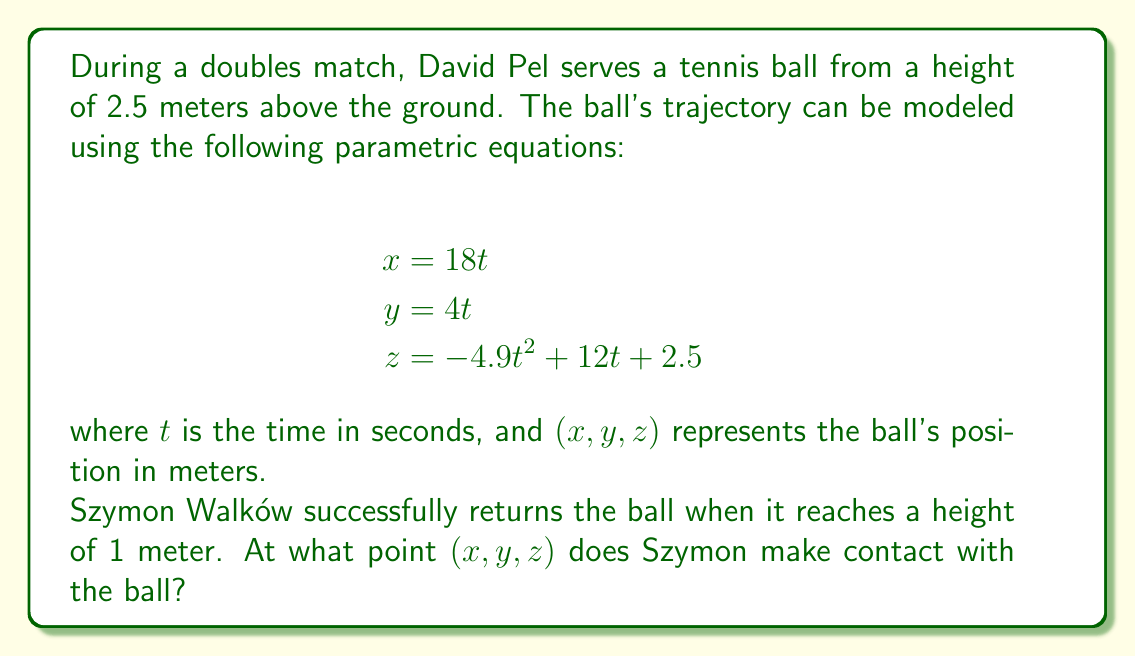Teach me how to tackle this problem. To solve this problem, we need to follow these steps:

1) First, we need to find the time $t$ when the ball reaches a height of 1 meter. This occurs when $z = 1$.

2) We can set up the equation:
   $$1 = -4.9t^2 + 12t + 2.5$$

3) Rearranging the equation:
   $$4.9t^2 - 12t - 1.5 = 0$$

4) This is a quadratic equation in the form $at^2 + bt + c = 0$, where:
   $a = 4.9$, $b = -12$, and $c = -1.5$

5) We can solve this using the quadratic formula: $t = \frac{-b \pm \sqrt{b^2 - 4ac}}{2a}$

6) Substituting the values:
   $$t = \frac{12 \pm \sqrt{(-12)^2 - 4(4.9)(-1.5)}}{2(4.9)}$$

7) Simplifying:
   $$t = \frac{12 \pm \sqrt{144 + 29.4}}{9.8} = \frac{12 \pm \sqrt{173.4}}{9.8}$$

8) This gives us two solutions:
   $$t_1 \approx 2.45 \text{ seconds}$$
   $$t_2 \approx 0.12 \text{ seconds}$$

9) Since we're interested in when Szymon returns the ball, we'll use the larger value, $t \approx 2.45$ seconds.

10) Now we can substitute this value of $t$ into the parametric equations to find $x$, $y$, and $z$:

    $$\begin{align*}
    x &= 18(2.45) \approx 44.1 \text{ meters} \\
    y &= 4(2.45) \approx 9.8 \text{ meters} \\
    z &= -4.9(2.45)^2 + 12(2.45) + 2.5 = 1 \text{ meter}
    \end{align*}$$

Therefore, Szymon makes contact with the ball at approximately the point (44.1, 9.8, 1) in meters.
Answer: Szymon Walków returns the ball at approximately the point (44.1, 9.8, 1) meters. 